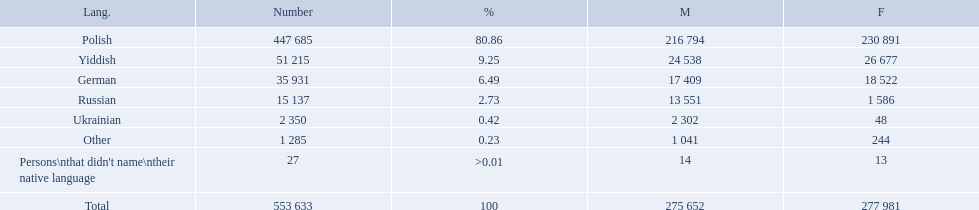What are all of the languages? Polish, Yiddish, German, Russian, Ukrainian, Other, Persons\nthat didn't name\ntheir native language. And how many people speak these languages? 447 685, 51 215, 35 931, 15 137, 2 350, 1 285, 27. Which language is used by most people? Polish. Which language options are listed? Polish, Yiddish, German, Russian, Ukrainian, Other, Persons\nthat didn't name\ntheir native language. Of these, which did .42% of the people select? Ukrainian. What are the percentages of people? 80.86, 9.25, 6.49, 2.73, 0.42, 0.23, >0.01. Which language is .42%? Ukrainian. 